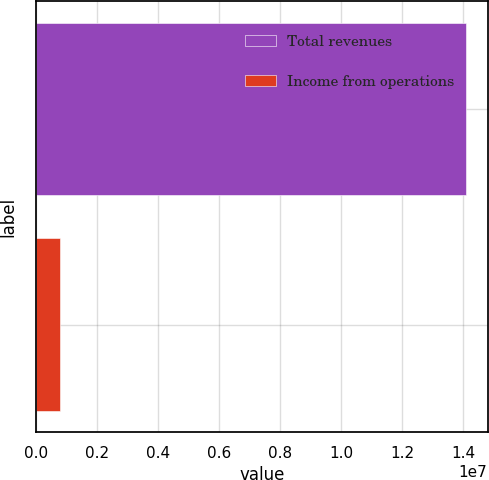Convert chart to OTSL. <chart><loc_0><loc_0><loc_500><loc_500><bar_chart><fcel>Total revenues<fcel>Income from operations<nl><fcel>1.40933e+07<fcel>772549<nl></chart> 